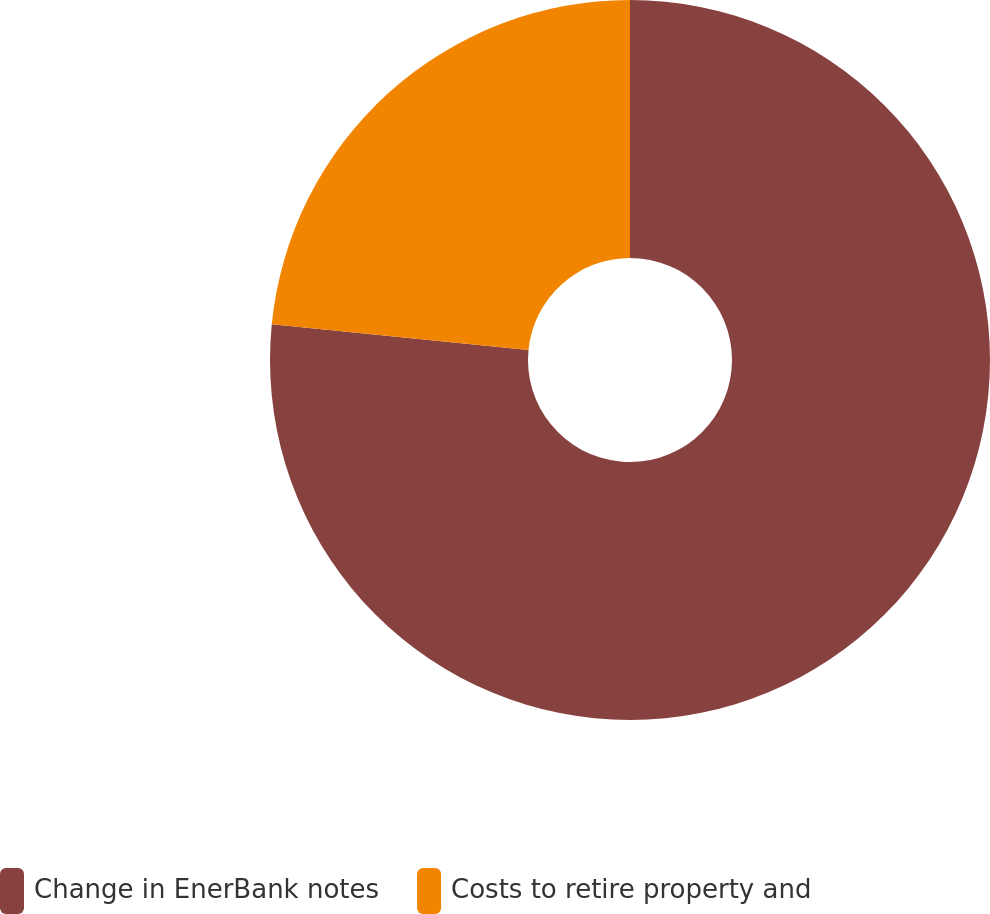Convert chart. <chart><loc_0><loc_0><loc_500><loc_500><pie_chart><fcel>Change in EnerBank notes<fcel>Costs to retire property and<nl><fcel>76.58%<fcel>23.42%<nl></chart> 